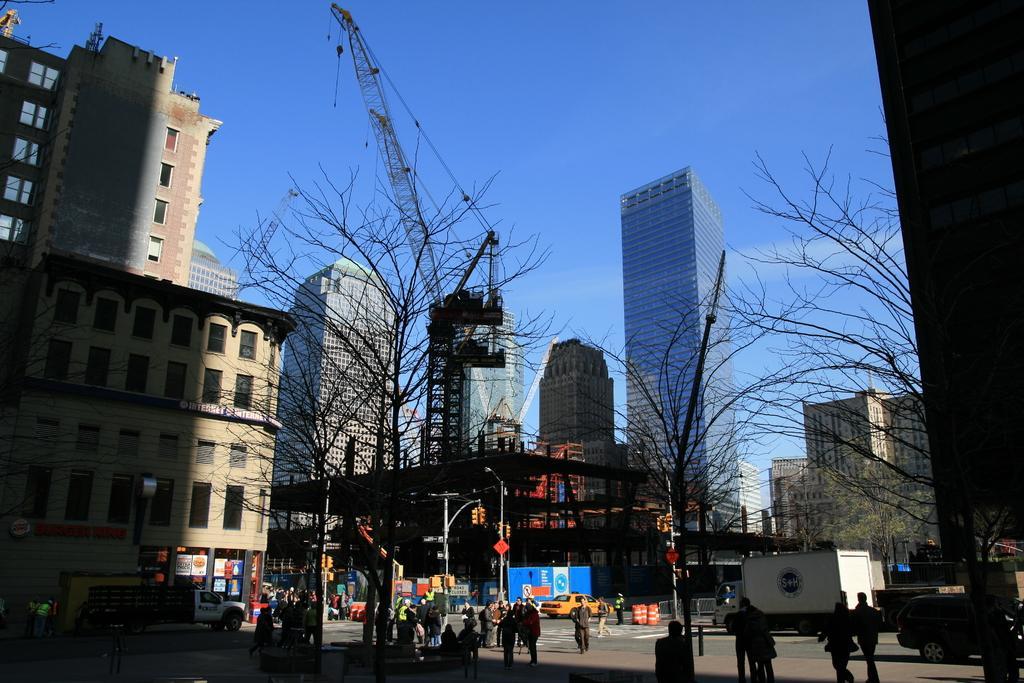How would you summarize this image in a sentence or two? In this image there are buildings, in front of the buildings there are few people and vehicles are on the road and there are trees. 